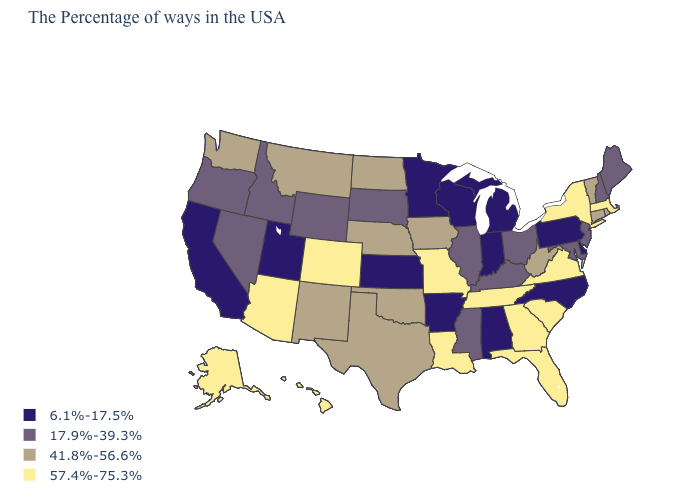Name the states that have a value in the range 17.9%-39.3%?
Answer briefly. Maine, New Hampshire, New Jersey, Maryland, Ohio, Kentucky, Illinois, Mississippi, South Dakota, Wyoming, Idaho, Nevada, Oregon. Among the states that border Tennessee , which have the lowest value?
Short answer required. North Carolina, Alabama, Arkansas. What is the value of South Carolina?
Keep it brief. 57.4%-75.3%. Which states have the lowest value in the USA?
Quick response, please. Delaware, Pennsylvania, North Carolina, Michigan, Indiana, Alabama, Wisconsin, Arkansas, Minnesota, Kansas, Utah, California. Among the states that border Idaho , which have the lowest value?
Keep it brief. Utah. Name the states that have a value in the range 41.8%-56.6%?
Keep it brief. Rhode Island, Vermont, Connecticut, West Virginia, Iowa, Nebraska, Oklahoma, Texas, North Dakota, New Mexico, Montana, Washington. Name the states that have a value in the range 17.9%-39.3%?
Give a very brief answer. Maine, New Hampshire, New Jersey, Maryland, Ohio, Kentucky, Illinois, Mississippi, South Dakota, Wyoming, Idaho, Nevada, Oregon. Does Wisconsin have the lowest value in the USA?
Be succinct. Yes. What is the value of Illinois?
Quick response, please. 17.9%-39.3%. Is the legend a continuous bar?
Be succinct. No. How many symbols are there in the legend?
Give a very brief answer. 4. Which states have the highest value in the USA?
Write a very short answer. Massachusetts, New York, Virginia, South Carolina, Florida, Georgia, Tennessee, Louisiana, Missouri, Colorado, Arizona, Alaska, Hawaii. Name the states that have a value in the range 6.1%-17.5%?
Short answer required. Delaware, Pennsylvania, North Carolina, Michigan, Indiana, Alabama, Wisconsin, Arkansas, Minnesota, Kansas, Utah, California. Does Arkansas have the lowest value in the USA?
Quick response, please. Yes. Name the states that have a value in the range 57.4%-75.3%?
Keep it brief. Massachusetts, New York, Virginia, South Carolina, Florida, Georgia, Tennessee, Louisiana, Missouri, Colorado, Arizona, Alaska, Hawaii. 